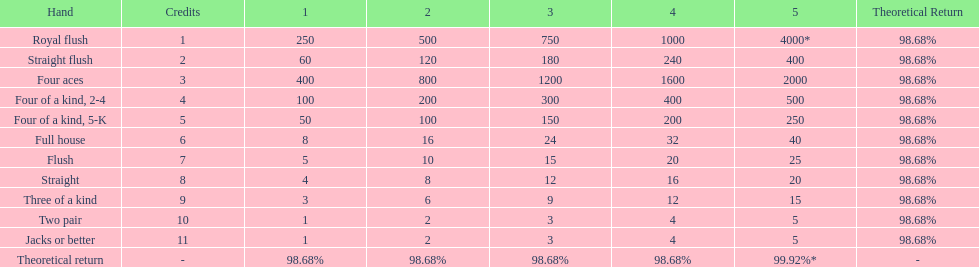Which is a higher standing hand: a straight or a flush? Flush. 